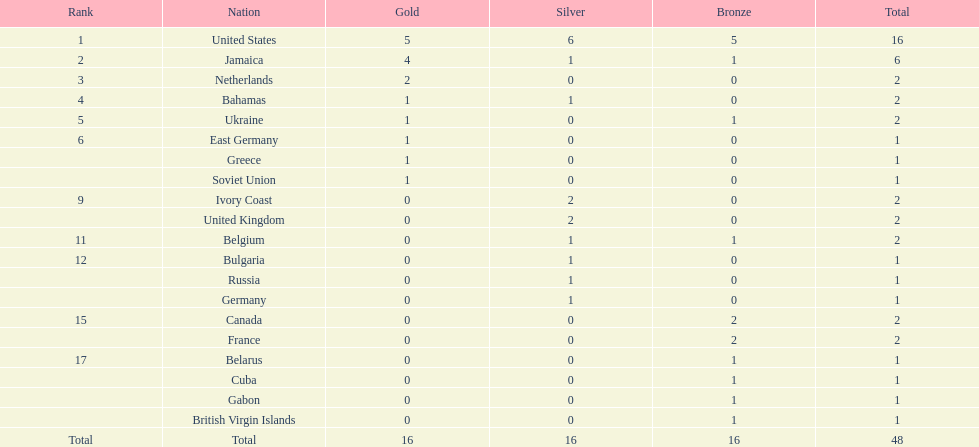What is the typical amount of gold medals secured by the leading 5 nations? 2.6. 